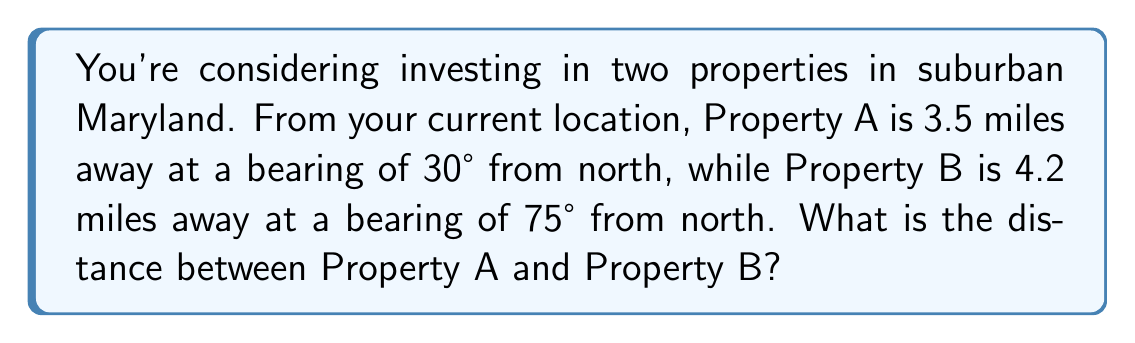Give your solution to this math problem. Let's solve this problem using the law of cosines for triangulation:

1) First, we need to identify the triangle formed by your current location and the two properties. Let's call the angle between the two bearings θ.

2) Calculate θ:
   θ = 75° - 30° = 45°

3) We now have a triangle with the following information:
   - Side a = 3.5 miles (distance to Property A)
   - Side b = 4.2 miles (distance to Property B)
   - Angle C = 45° (angle between the two bearings)

4) We can use the law of cosines to find the third side (c), which is the distance between Property A and Property B:

   $$c^2 = a^2 + b^2 - 2ab \cos(C)$$

5) Let's substitute our values:

   $$c^2 = 3.5^2 + 4.2^2 - 2(3.5)(4.2) \cos(45°)$$

6) Simplify:
   $$c^2 = 12.25 + 17.64 - 29.4 \cos(45°)$$
   $$c^2 = 29.89 - 29.4 (0.7071)$$
   $$c^2 = 29.89 - 20.79$$
   $$c^2 = 9.10$$

7) Take the square root of both sides:
   $$c = \sqrt{9.10} \approx 3.02$$

Therefore, the distance between Property A and Property B is approximately 3.02 miles.
Answer: 3.02 miles 